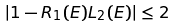Convert formula to latex. <formula><loc_0><loc_0><loc_500><loc_500>| 1 - R _ { 1 } ( E ) L _ { 2 } ( E ) | \leq 2</formula> 